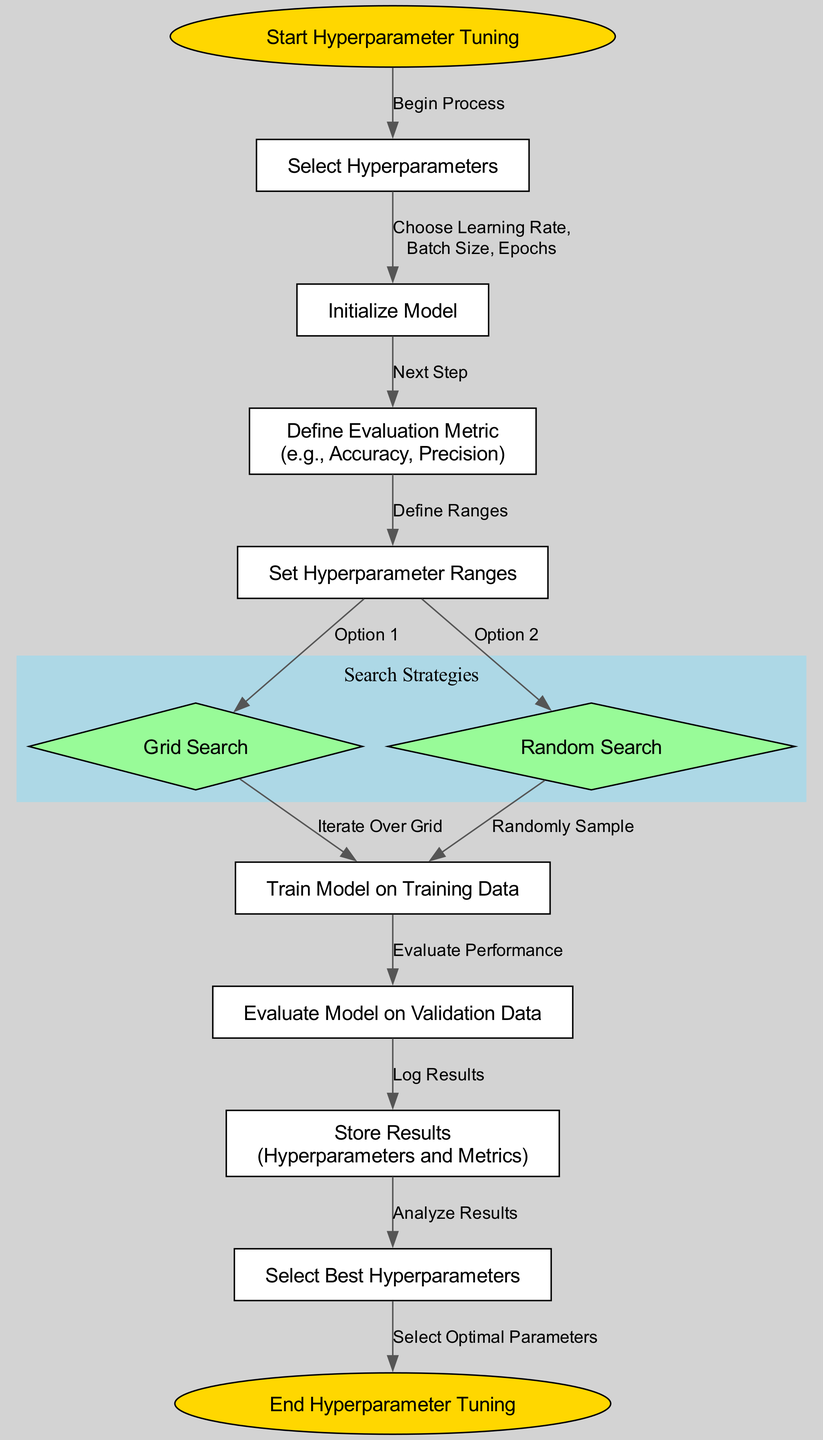What is the starting point of hyperparameter tuning? The diagram indicates that the first step is labeled "Start Hyperparameter Tuning," which is the initial node in the flowchart.
Answer: Start Hyperparameter Tuning How many search strategies are presented in the diagram? The diagram identifies two search strategies: "Grid Search" and "Random Search." Therefore, there are two distinct strategies depicted.
Answer: 2 What step comes after initializing the model? In the flowchart, after the "Initialize Model" step, the next step is defined as "Define Evaluation Metric (e.g., Accuracy, Precision)." This establishes the evaluation standards used later.
Answer: Define Evaluation Metric (e.g., Accuracy, Precision) What do you do after you set the hyperparameter ranges? Following the step "Set Hyperparameter Ranges," the diagram presents two options: "Grid Search" or "Random Search." This indicates what decisions need to be made at this point.
Answer: Grid Search or Random Search Which node indicates the final outcome of the hyperparameter tuning process? The last node in the flowchart labeled "End Hyperparameter Tuning" indicates the completion of the tuning process, marking the conclusion of all preceding steps.
Answer: End Hyperparameter Tuning What is the evaluation metric mentioned in the diagram? The diagram specifies that the evaluation metric can be "Accuracy," "Precision," or similar metrics, providing a clear guideline for performance assessment.
Answer: Accuracy, Precision What happens in the "Train Model on Training Data" step? During this step, the model is trained using the defined training dataset, which leads to the subsequent evaluation of its performance on validation data.
Answer: Train Model on Training Data What is the purpose of the "Store Results" step? This step facilitates the logging of hyperparameter configurations alongside their corresponding evaluation metrics, allowing for a proper analysis and selection of the best performing hyperparameters later in the process.
Answer: Store Results (Hyperparameters and Metrics) What is indicated by the node "Select Best Hyperparameters"? This node signifies the process of analyzing the stored results to identify which hyperparameter configuration yielded the best performance, thus optimizing the model's settings.
Answer: Select Best Hyperparameters 